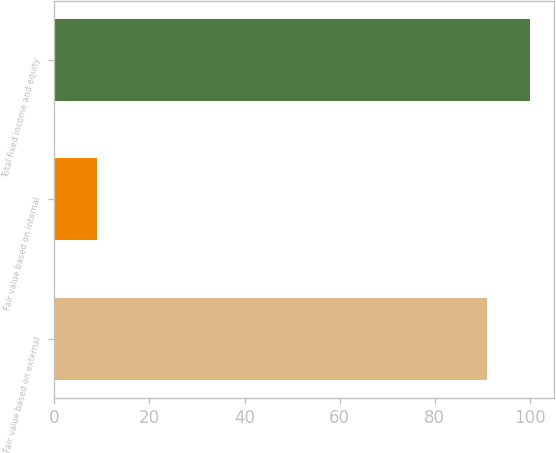Convert chart. <chart><loc_0><loc_0><loc_500><loc_500><bar_chart><fcel>Fair value based on external<fcel>Fair value based on internal<fcel>Total fixed income and equity<nl><fcel>91<fcel>9<fcel>100.1<nl></chart> 